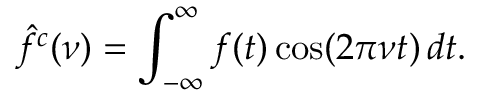<formula> <loc_0><loc_0><loc_500><loc_500>{ \hat { f } } ^ { c } ( \nu ) = \int _ { - \infty } ^ { \infty } f ( t ) \cos ( 2 \pi \nu t ) \, d t .</formula> 